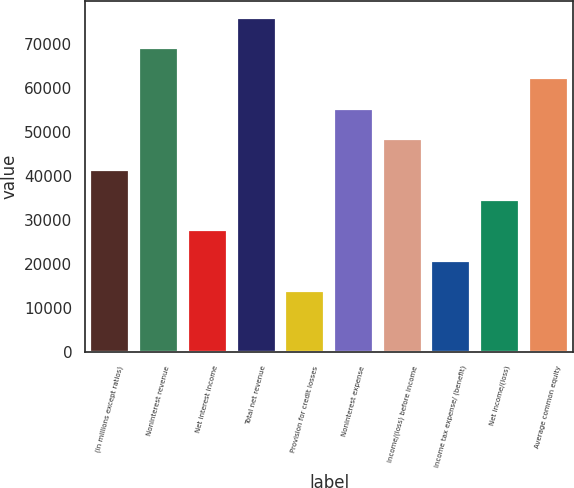<chart> <loc_0><loc_0><loc_500><loc_500><bar_chart><fcel>(in millions except ratios)<fcel>Noninterest revenue<fcel>Net interest income<fcel>Total net revenue<fcel>Provision for credit losses<fcel>Noninterest expense<fcel>Income/(loss) before income<fcel>Income tax expense/ (benefit)<fcel>Net income/(loss)<fcel>Average common equity<nl><fcel>41408.6<fcel>68997<fcel>27614.4<fcel>75894.1<fcel>13820.2<fcel>55202.8<fcel>48305.7<fcel>20717.3<fcel>34511.5<fcel>62099.9<nl></chart> 